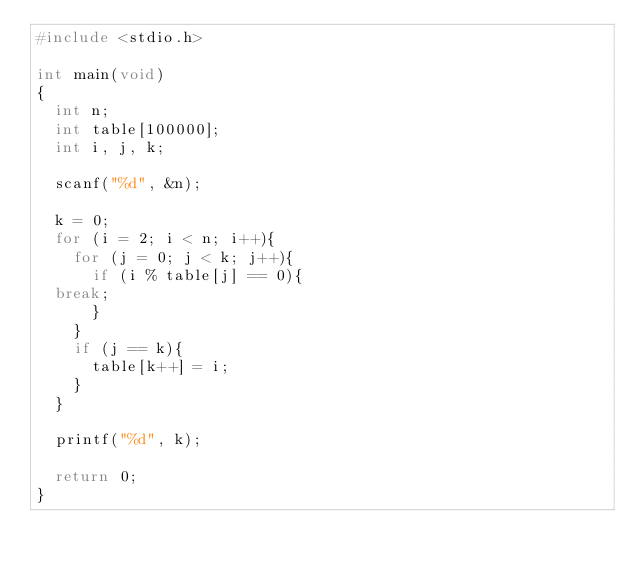Convert code to text. <code><loc_0><loc_0><loc_500><loc_500><_C_>#include <stdio.h>

int main(void)
{
  int n;
  int table[100000];
  int i, j, k;

  scanf("%d", &n);

  k = 0;
  for (i = 2; i < n; i++){
    for (j = 0; j < k; j++){
      if (i % table[j] == 0){
	break;
      }
    }
    if (j == k){
      table[k++] = i;
    }
  }

  printf("%d", k);

  return 0;
}</code> 